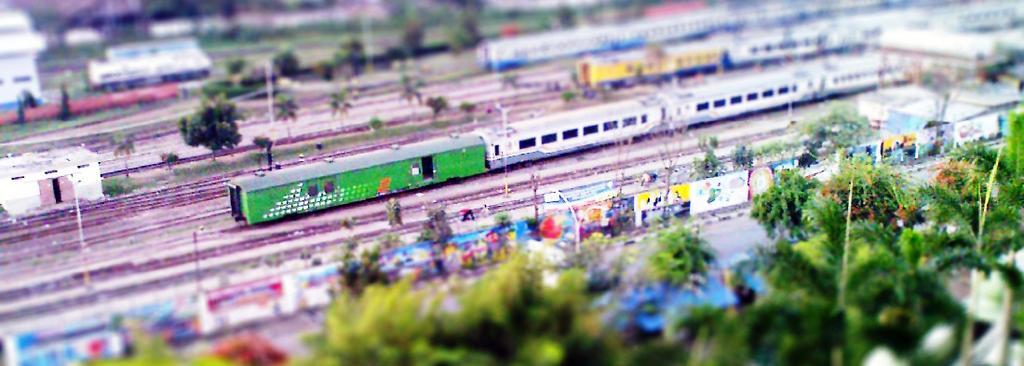Can you describe this image briefly? In this picture I can see the miniature set where I can see number of trees in front and in the middle of this picture I can see the tracks on which there are 3 trains and I see few more trees. In the background I can see few buildings and I see that it is blurred. 